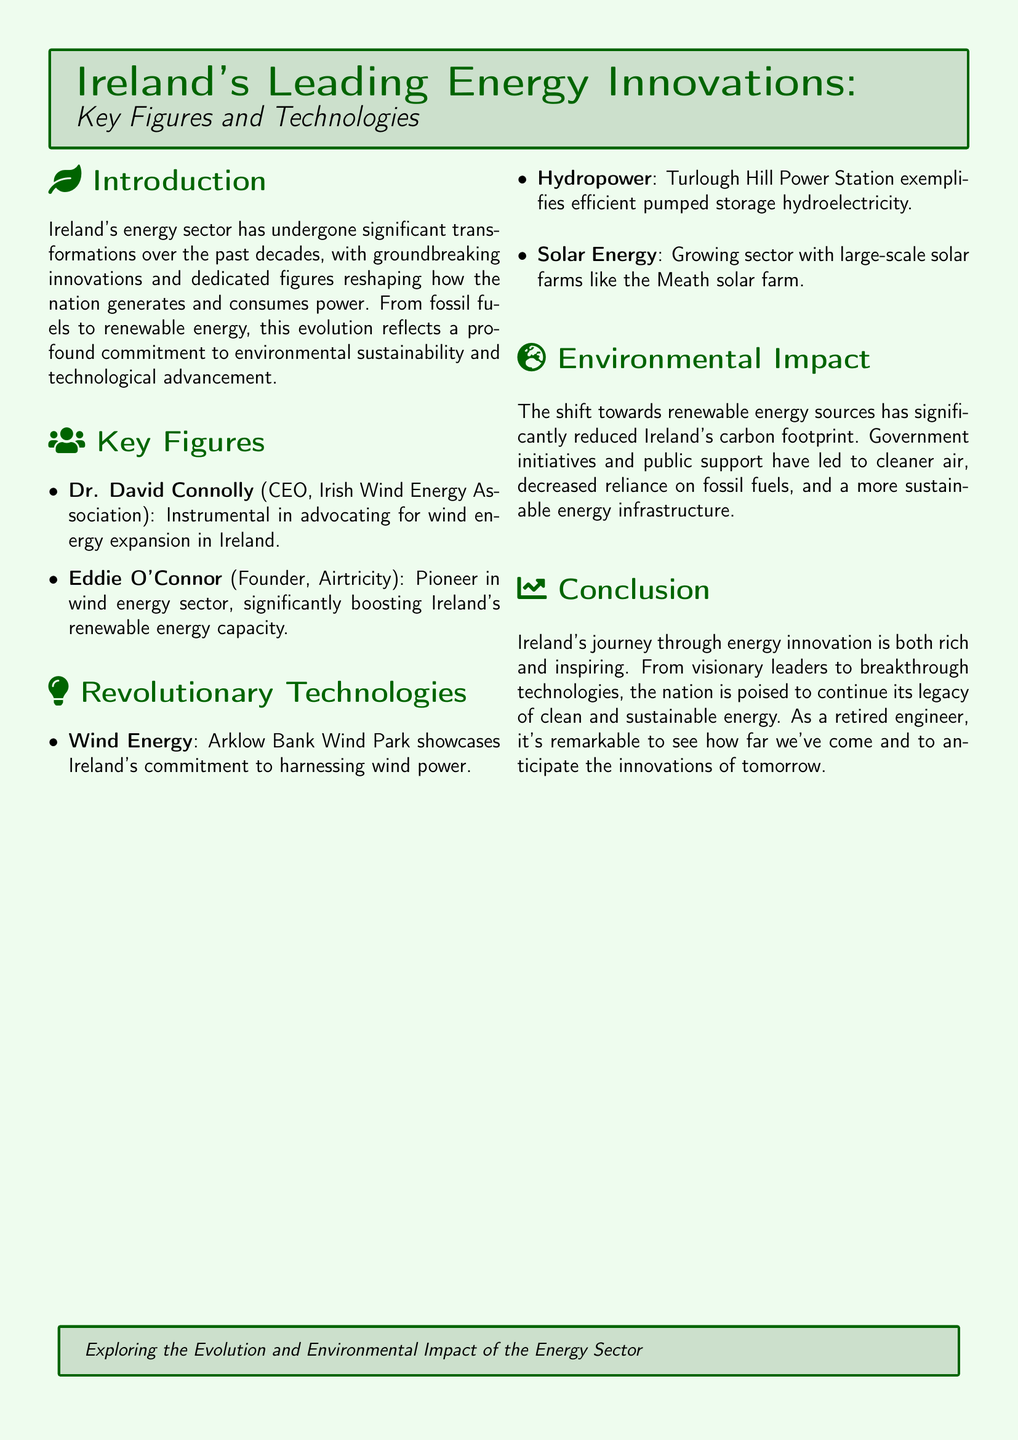What is the role of Dr. David Connolly? Dr. David Connolly is the CEO of the Irish Wind Energy Association and is instrumental in advocating for wind energy expansion in Ireland.
Answer: CEO, Irish Wind Energy Association What technology is showcased by Arklow Bank Wind Park? Arklow Bank Wind Park demonstrates Ireland's commitment to harnessing wind power.
Answer: Wind Energy Which power station exemplifies efficient pumped storage hydroelectricity? The Turlough Hill Power Station is cited as an example of efficient pumped storage hydroelectricity.
Answer: Turlough Hill Power Station What renewable energy sector is growing with large-scale solar farms? The document mentions that solar energy is a growing sector in Ireland.
Answer: Solar Energy Who is the founder of Airtricity? Eddie O'Connor is the founder of Airtricity and a pioneer in the wind energy sector.
Answer: Eddie O'Connor What has the shift towards renewable energy sources significantly reduced in Ireland? The transition to renewable energy has significantly reduced Ireland's carbon footprint.
Answer: Carbon footprint What type of document is this? This document serves as a Playbill, focusing on energy innovations in Ireland.
Answer: Playbill What does the conclusion suggest about Ireland's future in energy? The conclusion indicates that Ireland is poised to continue its legacy of clean and sustainable energy.
Answer: Clean and sustainable energy 